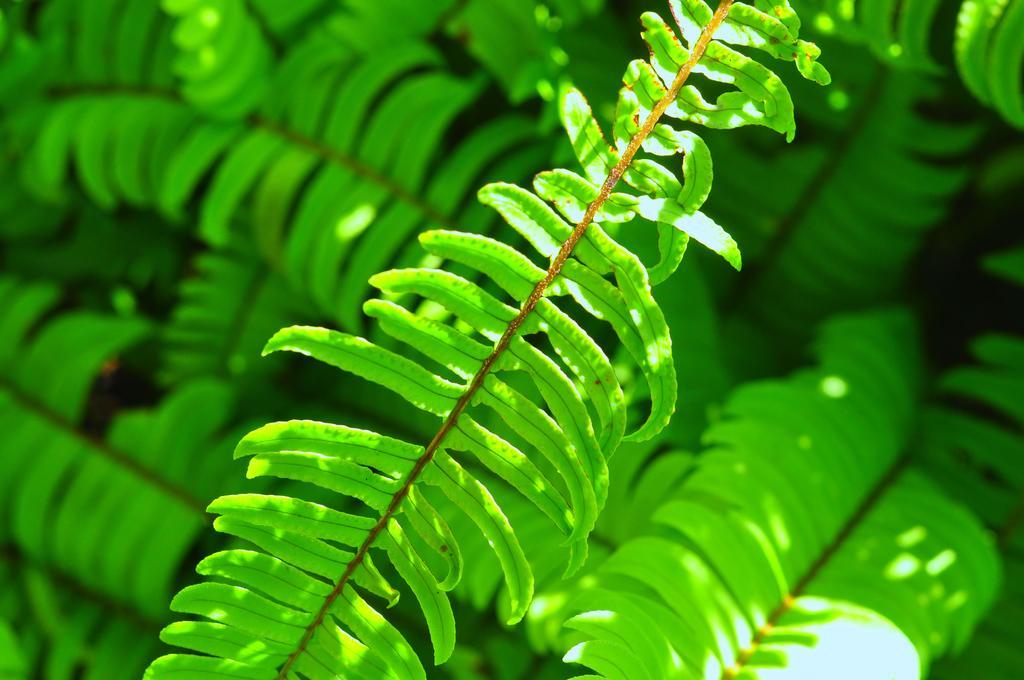Could you give a brief overview of what you see in this image? In this picture we can see leaves. 